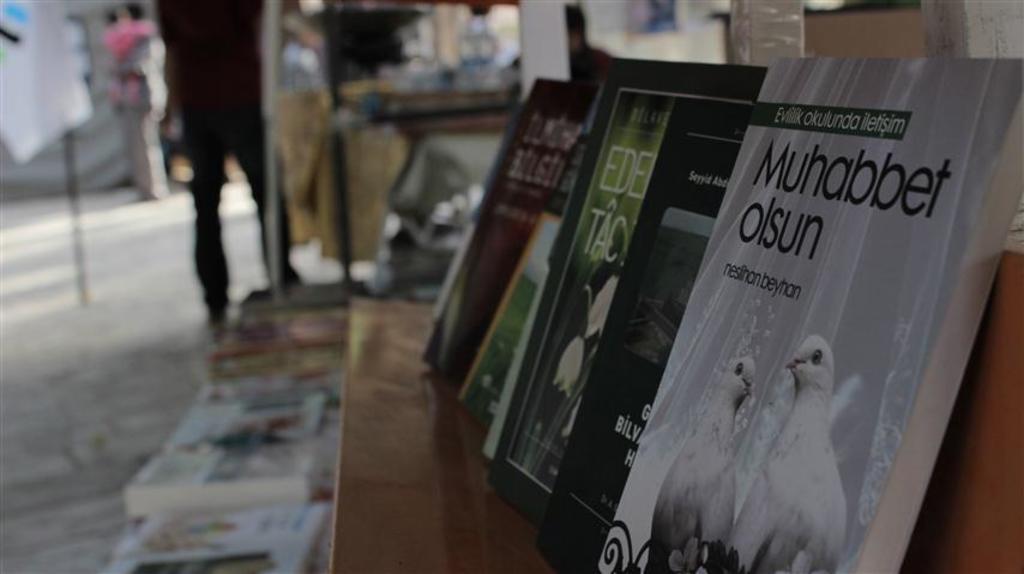What are the titles of the books?
Offer a very short reply. Muhabbet olsun. What is written on the green background of the book muhabbet olsun?
Your response must be concise. Evlilik okulunda iletisim. 